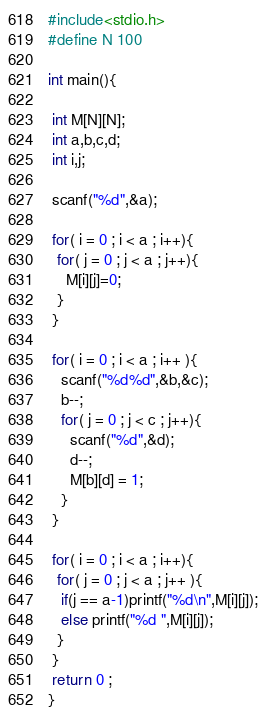<code> <loc_0><loc_0><loc_500><loc_500><_C_>#include<stdio.h>
#define N 100

int main(){
 
 int M[N][N];
 int a,b,c,d;
 int i,j;
 
 scanf("%d",&a);
 
 for( i = 0 ; i < a ; i++){
  for( j = 0 ; j < a ; j++){
    M[i][j]=0;
  }
 }
 
 for( i = 0 ; i < a ; i++ ){
   scanf("%d%d",&b,&c);
   b--;
   for( j = 0 ; j < c ; j++){
     scanf("%d",&d);
     d--;
     M[b][d] = 1;
   }
 }

 for( i = 0 ; i < a ; i++){
  for( j = 0 ; j < a ; j++ ){
   if(j == a-1)printf("%d\n",M[i][j]);
   else printf("%d ",M[i][j]);
  }
 }
 return 0 ;
}</code> 